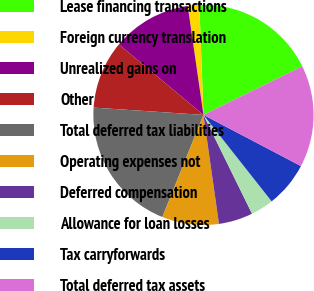Convert chart. <chart><loc_0><loc_0><loc_500><loc_500><pie_chart><fcel>Lease financing transactions<fcel>Foreign currency translation<fcel>Unrealized gains on<fcel>Other<fcel>Total deferred tax liabilities<fcel>Operating expenses not<fcel>Deferred compensation<fcel>Allowance for loan losses<fcel>Tax carryforwards<fcel>Total deferred tax assets<nl><fcel>18.31%<fcel>1.69%<fcel>11.66%<fcel>10.0%<fcel>19.97%<fcel>8.34%<fcel>5.02%<fcel>3.36%<fcel>6.68%<fcel>14.98%<nl></chart> 